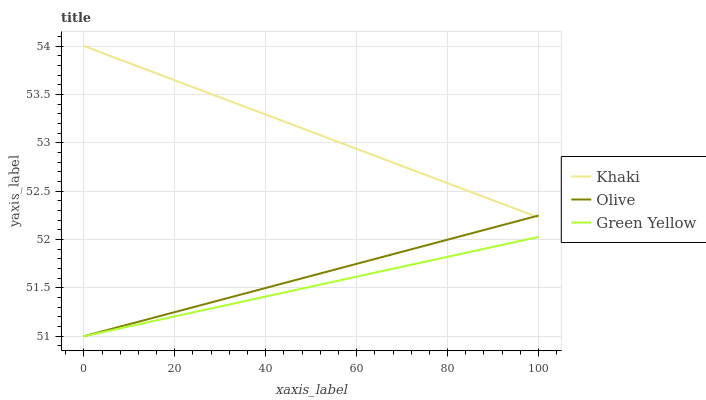Does Green Yellow have the minimum area under the curve?
Answer yes or no. Yes. Does Khaki have the maximum area under the curve?
Answer yes or no. Yes. Does Khaki have the minimum area under the curve?
Answer yes or no. No. Does Green Yellow have the maximum area under the curve?
Answer yes or no. No. Is Khaki the smoothest?
Answer yes or no. Yes. Is Olive the roughest?
Answer yes or no. Yes. Is Green Yellow the smoothest?
Answer yes or no. No. Is Green Yellow the roughest?
Answer yes or no. No. Does Olive have the lowest value?
Answer yes or no. Yes. Does Khaki have the lowest value?
Answer yes or no. No. Does Khaki have the highest value?
Answer yes or no. Yes. Does Green Yellow have the highest value?
Answer yes or no. No. Is Green Yellow less than Khaki?
Answer yes or no. Yes. Is Khaki greater than Green Yellow?
Answer yes or no. Yes. Does Olive intersect Green Yellow?
Answer yes or no. Yes. Is Olive less than Green Yellow?
Answer yes or no. No. Is Olive greater than Green Yellow?
Answer yes or no. No. Does Green Yellow intersect Khaki?
Answer yes or no. No. 